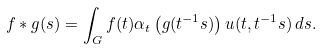Convert formula to latex. <formula><loc_0><loc_0><loc_500><loc_500>f * g ( s ) = \int _ { G } f ( t ) \alpha _ { t } \left ( g ( t ^ { - 1 } s ) \right ) u ( t , t ^ { - 1 } s ) \, d s .</formula> 